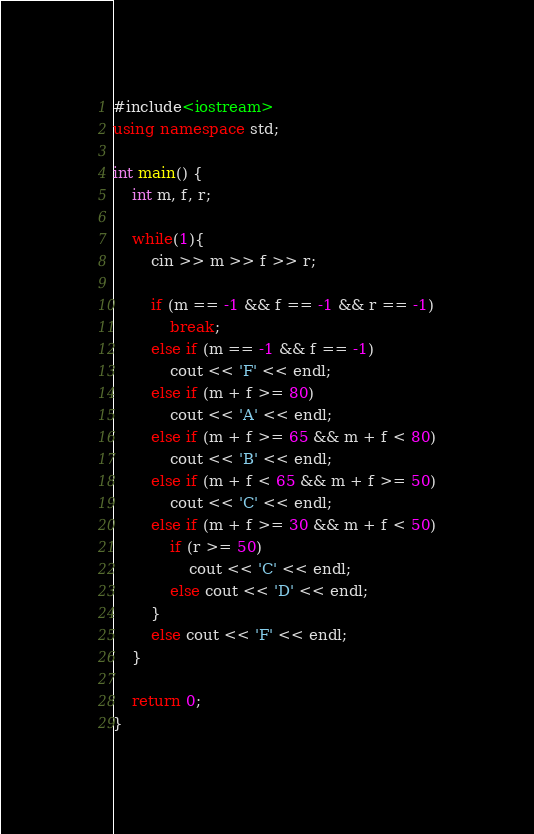Convert code to text. <code><loc_0><loc_0><loc_500><loc_500><_C++_>#include<iostream>
using namespace std;

int main() {
	int m, f, r;
	
	while(1){
		cin >> m >> f >> r;

		if (m == -1 && f == -1 && r == -1)
			break;
		else if (m == -1 && f == -1)
			cout << 'F' << endl;
		else if (m + f >= 80)
			cout << 'A' << endl;
		else if (m + f >= 65 && m + f < 80)
			cout << 'B' << endl;
		else if (m + f < 65 && m + f >= 50)
			cout << 'C' << endl;
		else if (m + f >= 30 && m + f < 50)
			if (r >= 50)
				cout << 'C' << endl;
			else cout << 'D' << endl;
		}
		else cout << 'F' << endl;
	}

	return 0;
}</code> 